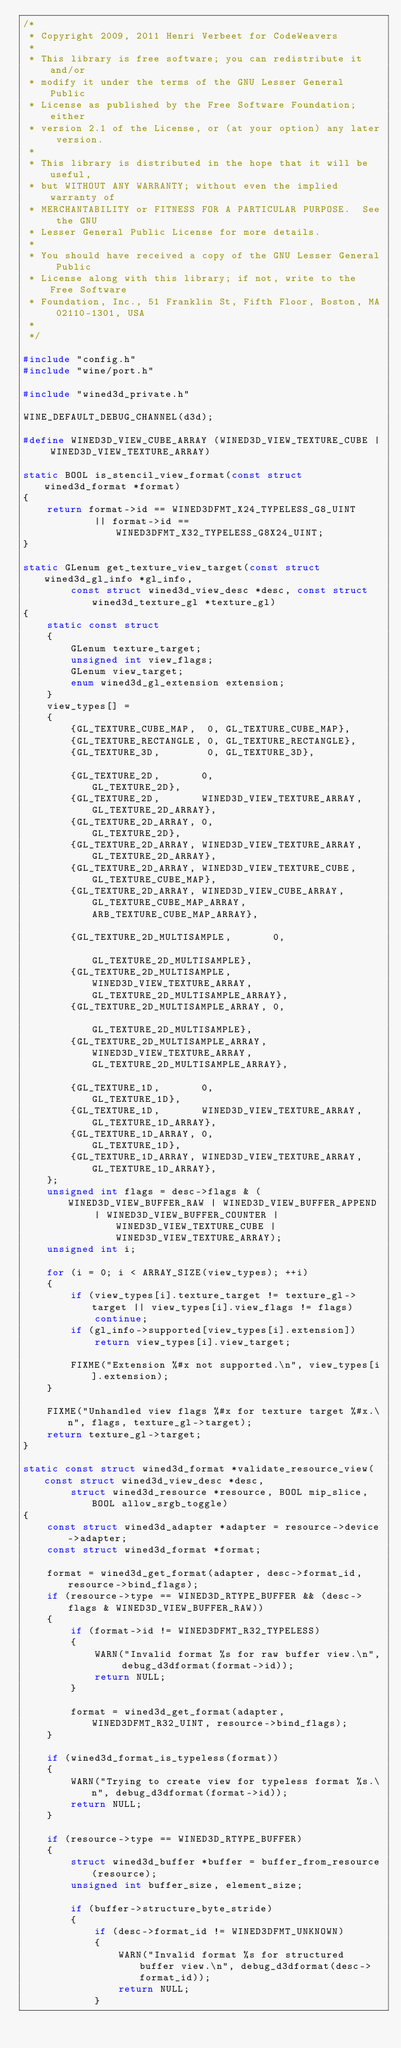Convert code to text. <code><loc_0><loc_0><loc_500><loc_500><_C_>/*
 * Copyright 2009, 2011 Henri Verbeet for CodeWeavers
 *
 * This library is free software; you can redistribute it and/or
 * modify it under the terms of the GNU Lesser General Public
 * License as published by the Free Software Foundation; either
 * version 2.1 of the License, or (at your option) any later version.
 *
 * This library is distributed in the hope that it will be useful,
 * but WITHOUT ANY WARRANTY; without even the implied warranty of
 * MERCHANTABILITY or FITNESS FOR A PARTICULAR PURPOSE.  See the GNU
 * Lesser General Public License for more details.
 *
 * You should have received a copy of the GNU Lesser General Public
 * License along with this library; if not, write to the Free Software
 * Foundation, Inc., 51 Franklin St, Fifth Floor, Boston, MA 02110-1301, USA
 *
 */

#include "config.h"
#include "wine/port.h"

#include "wined3d_private.h"

WINE_DEFAULT_DEBUG_CHANNEL(d3d);

#define WINED3D_VIEW_CUBE_ARRAY (WINED3D_VIEW_TEXTURE_CUBE | WINED3D_VIEW_TEXTURE_ARRAY)

static BOOL is_stencil_view_format(const struct wined3d_format *format)
{
    return format->id == WINED3DFMT_X24_TYPELESS_G8_UINT
            || format->id == WINED3DFMT_X32_TYPELESS_G8X24_UINT;
}

static GLenum get_texture_view_target(const struct wined3d_gl_info *gl_info,
        const struct wined3d_view_desc *desc, const struct wined3d_texture_gl *texture_gl)
{
    static const struct
    {
        GLenum texture_target;
        unsigned int view_flags;
        GLenum view_target;
        enum wined3d_gl_extension extension;
    }
    view_types[] =
    {
        {GL_TEXTURE_CUBE_MAP,  0, GL_TEXTURE_CUBE_MAP},
        {GL_TEXTURE_RECTANGLE, 0, GL_TEXTURE_RECTANGLE},
        {GL_TEXTURE_3D,        0, GL_TEXTURE_3D},

        {GL_TEXTURE_2D,       0,                          GL_TEXTURE_2D},
        {GL_TEXTURE_2D,       WINED3D_VIEW_TEXTURE_ARRAY, GL_TEXTURE_2D_ARRAY},
        {GL_TEXTURE_2D_ARRAY, 0,                          GL_TEXTURE_2D},
        {GL_TEXTURE_2D_ARRAY, WINED3D_VIEW_TEXTURE_ARRAY, GL_TEXTURE_2D_ARRAY},
        {GL_TEXTURE_2D_ARRAY, WINED3D_VIEW_TEXTURE_CUBE,  GL_TEXTURE_CUBE_MAP},
        {GL_TEXTURE_2D_ARRAY, WINED3D_VIEW_CUBE_ARRAY,    GL_TEXTURE_CUBE_MAP_ARRAY, ARB_TEXTURE_CUBE_MAP_ARRAY},

        {GL_TEXTURE_2D_MULTISAMPLE,       0,                          GL_TEXTURE_2D_MULTISAMPLE},
        {GL_TEXTURE_2D_MULTISAMPLE,       WINED3D_VIEW_TEXTURE_ARRAY, GL_TEXTURE_2D_MULTISAMPLE_ARRAY},
        {GL_TEXTURE_2D_MULTISAMPLE_ARRAY, 0,                          GL_TEXTURE_2D_MULTISAMPLE},
        {GL_TEXTURE_2D_MULTISAMPLE_ARRAY, WINED3D_VIEW_TEXTURE_ARRAY, GL_TEXTURE_2D_MULTISAMPLE_ARRAY},

        {GL_TEXTURE_1D,       0,                          GL_TEXTURE_1D},
        {GL_TEXTURE_1D,       WINED3D_VIEW_TEXTURE_ARRAY, GL_TEXTURE_1D_ARRAY},
        {GL_TEXTURE_1D_ARRAY, 0,                          GL_TEXTURE_1D},
        {GL_TEXTURE_1D_ARRAY, WINED3D_VIEW_TEXTURE_ARRAY, GL_TEXTURE_1D_ARRAY},
    };
    unsigned int flags = desc->flags & (WINED3D_VIEW_BUFFER_RAW | WINED3D_VIEW_BUFFER_APPEND
            | WINED3D_VIEW_BUFFER_COUNTER | WINED3D_VIEW_TEXTURE_CUBE | WINED3D_VIEW_TEXTURE_ARRAY);
    unsigned int i;

    for (i = 0; i < ARRAY_SIZE(view_types); ++i)
    {
        if (view_types[i].texture_target != texture_gl->target || view_types[i].view_flags != flags)
            continue;
        if (gl_info->supported[view_types[i].extension])
            return view_types[i].view_target;

        FIXME("Extension %#x not supported.\n", view_types[i].extension);
    }

    FIXME("Unhandled view flags %#x for texture target %#x.\n", flags, texture_gl->target);
    return texture_gl->target;
}

static const struct wined3d_format *validate_resource_view(const struct wined3d_view_desc *desc,
        struct wined3d_resource *resource, BOOL mip_slice, BOOL allow_srgb_toggle)
{
    const struct wined3d_adapter *adapter = resource->device->adapter;
    const struct wined3d_format *format;

    format = wined3d_get_format(adapter, desc->format_id, resource->bind_flags);
    if (resource->type == WINED3D_RTYPE_BUFFER && (desc->flags & WINED3D_VIEW_BUFFER_RAW))
    {
        if (format->id != WINED3DFMT_R32_TYPELESS)
        {
            WARN("Invalid format %s for raw buffer view.\n", debug_d3dformat(format->id));
            return NULL;
        }

        format = wined3d_get_format(adapter, WINED3DFMT_R32_UINT, resource->bind_flags);
    }

    if (wined3d_format_is_typeless(format))
    {
        WARN("Trying to create view for typeless format %s.\n", debug_d3dformat(format->id));
        return NULL;
    }

    if (resource->type == WINED3D_RTYPE_BUFFER)
    {
        struct wined3d_buffer *buffer = buffer_from_resource(resource);
        unsigned int buffer_size, element_size;

        if (buffer->structure_byte_stride)
        {
            if (desc->format_id != WINED3DFMT_UNKNOWN)
            {
                WARN("Invalid format %s for structured buffer view.\n", debug_d3dformat(desc->format_id));
                return NULL;
            }
</code> 